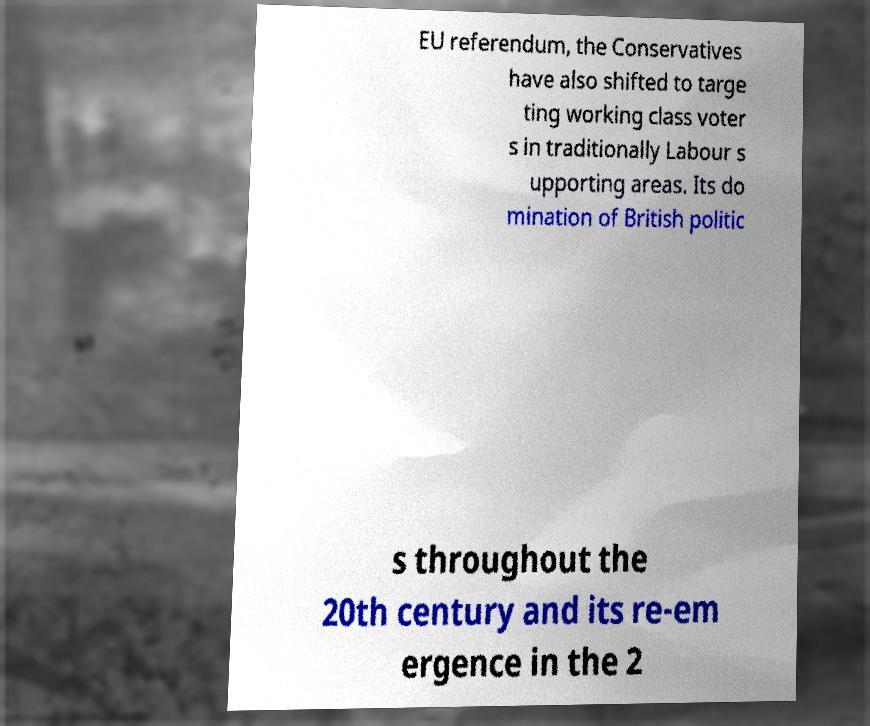For documentation purposes, I need the text within this image transcribed. Could you provide that? EU referendum, the Conservatives have also shifted to targe ting working class voter s in traditionally Labour s upporting areas. Its do mination of British politic s throughout the 20th century and its re-em ergence in the 2 